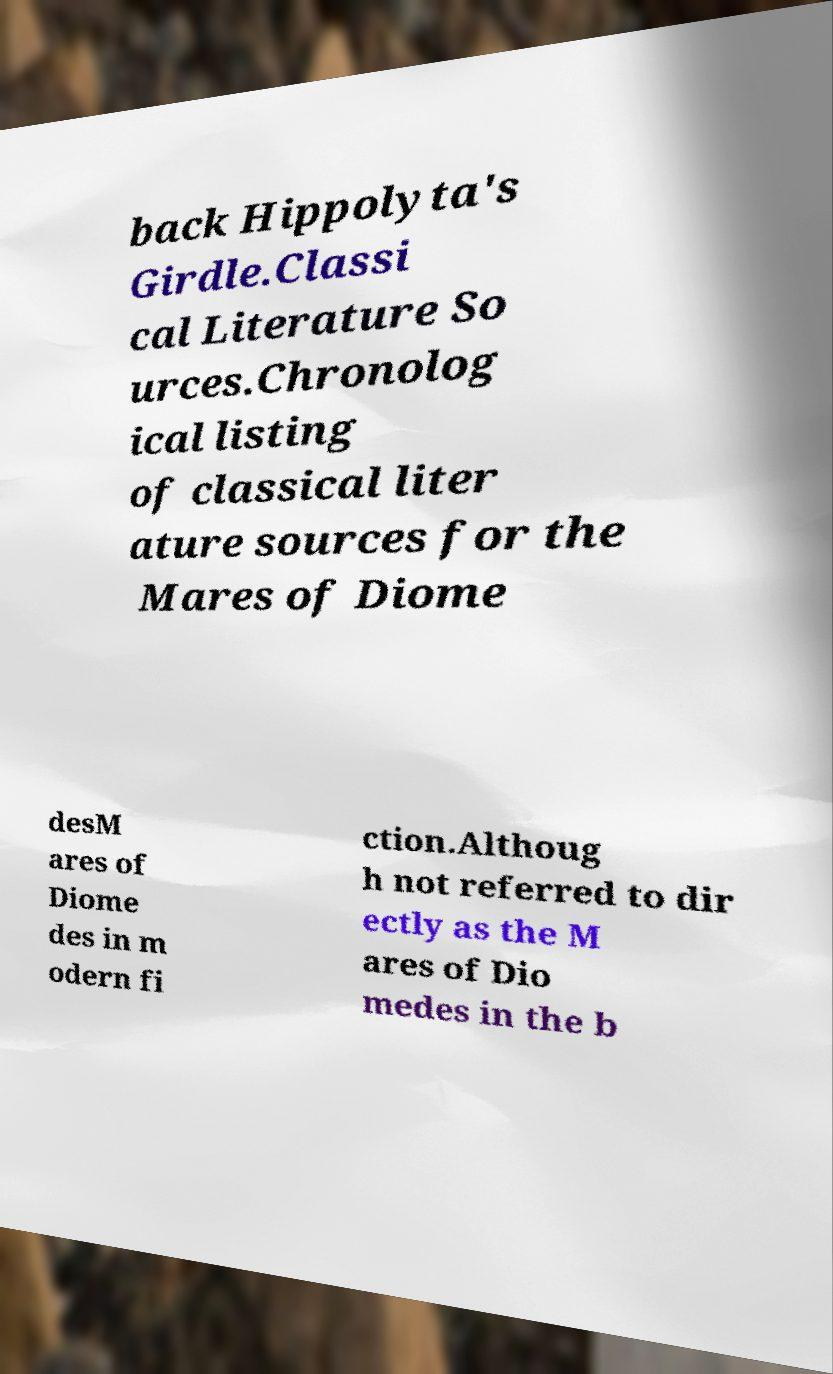Can you accurately transcribe the text from the provided image for me? back Hippolyta's Girdle.Classi cal Literature So urces.Chronolog ical listing of classical liter ature sources for the Mares of Diome desM ares of Diome des in m odern fi ction.Althoug h not referred to dir ectly as the M ares of Dio medes in the b 